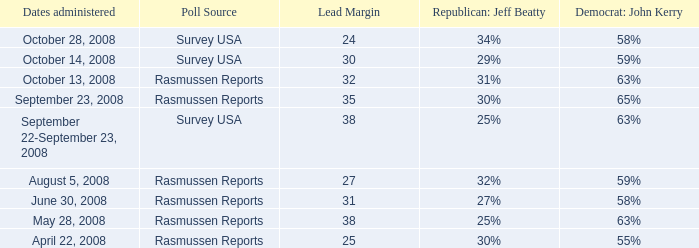What was the percentage for john kerry on april 22, 2008? 55%. 